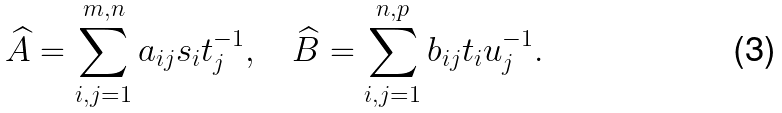Convert formula to latex. <formula><loc_0><loc_0><loc_500><loc_500>\widehat { A } = \sum _ { i , j = 1 } ^ { m , n } a _ { i j } s _ { i } t _ { j } ^ { - 1 } , \quad \widehat { B } = \sum _ { i , j = 1 } ^ { n , p } b _ { i j } t _ { i } u _ { j } ^ { - 1 } .</formula> 